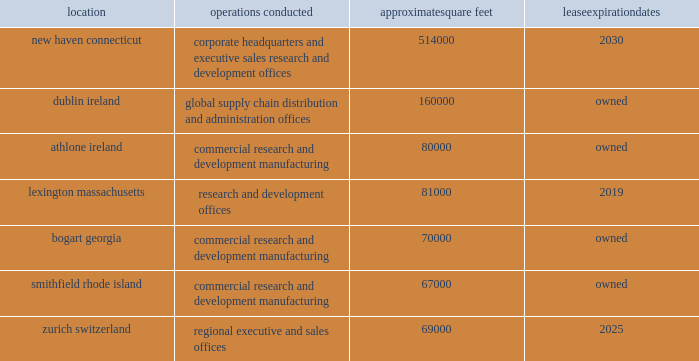Risks related to our common stock our stock price is extremely volatile .
The trading price of our common stock has been extremely volatile and may continue to be volatile in the future .
Many factors could have an impact on our stock price , including fluctuations in our or our competitors 2019 operating results , clinical trial results or adverse events associated with our products , product development by us or our competitors , changes in laws , including healthcare , tax or intellectual property laws , intellectual property developments , changes in reimbursement or drug pricing , the existence or outcome of litigation or government proceedings , including the sec/doj investigation , failure to resolve , delays in resolving or other developments with respect to the issues raised in the warning letter , acquisitions or other strategic transactions , and the perceptions of our investors that we are not performing or meeting expectations .
The trading price of the common stock of many biopharmaceutical companies , including ours , has experienced extreme price and volume fluctuations , which have at times been unrelated to the operating performance of the companies whose stocks were affected .
Anti-takeover provisions in our charter and bylaws and under delaware law could make a third-party acquisition of us difficult and may frustrate any attempt to remove or replace our current management .
Our corporate charter and by-law provisions may discourage certain types of transactions involving an actual or potential change of control that might be beneficial to us or our stockholders .
Our bylaws provide that special meetings of our stockholders may be called only by the chairman of the board , the president , the secretary , or a majority of the board of directors , or upon the written request of stockholders who together own of record 25% ( 25 % ) of the outstanding stock of all classes entitled to vote at such meeting .
Our bylaws also specify that the authorized number of directors may be changed only by resolution of the board of directors .
Our charter does not include a provision for cumulative voting for directors , which may have enabled a minority stockholder holding a sufficient percentage of a class of shares to elect one or more directors .
Under our charter , our board of directors has the authority , without further action by stockholders , to designate up to 5 shares of preferred stock in one or more series .
The rights of the holders of common stock will be subject to , and may be adversely affected by , the rights of the holders of any class or series of preferred stock that may be issued in the future .
Because we are a delaware corporation , the anti-takeover provisions of delaware law could make it more difficult for a third party to acquire control of us , even if the change in control would be beneficial to stockholders .
We are subject to the provisions of section 203 of the delaware general laws , which prohibits a person who owns in excess of 15% ( 15 % ) of our outstanding voting stock from merging or combining with us for a period of three years after the date of the transaction in which the person acquired in excess of 15% ( 15 % ) of our outstanding voting stock , unless the merger or combination is approved in a prescribed manner .
Item 1b .
Unresolved staff comments .
Item 2 .
Properties .
We conduct our primary operations at the owned and leased facilities described below .
Location operations conducted approximate square feet expiration new haven , connecticut corporate headquarters and executive , sales , research and development offices 514000 2030 dublin , ireland global supply chain , distribution , and administration offices 160000 owned .
We believe that our administrative office space is adequate to meet our needs for the foreseeable future .
We also believe that our research and development facilities and our manufacturing facilities , together with third party manufacturing facilities , will be adequate for our on-going activities .
In addition to the locations above , we also lease space in other u.s .
Locations and in foreign countries to support our operations as a global organization. .
How many square feet are leased by the company? 
Computations: ((514000 + 81000) + 69000)
Answer: 664000.0. 